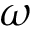Convert formula to latex. <formula><loc_0><loc_0><loc_500><loc_500>\omega</formula> 